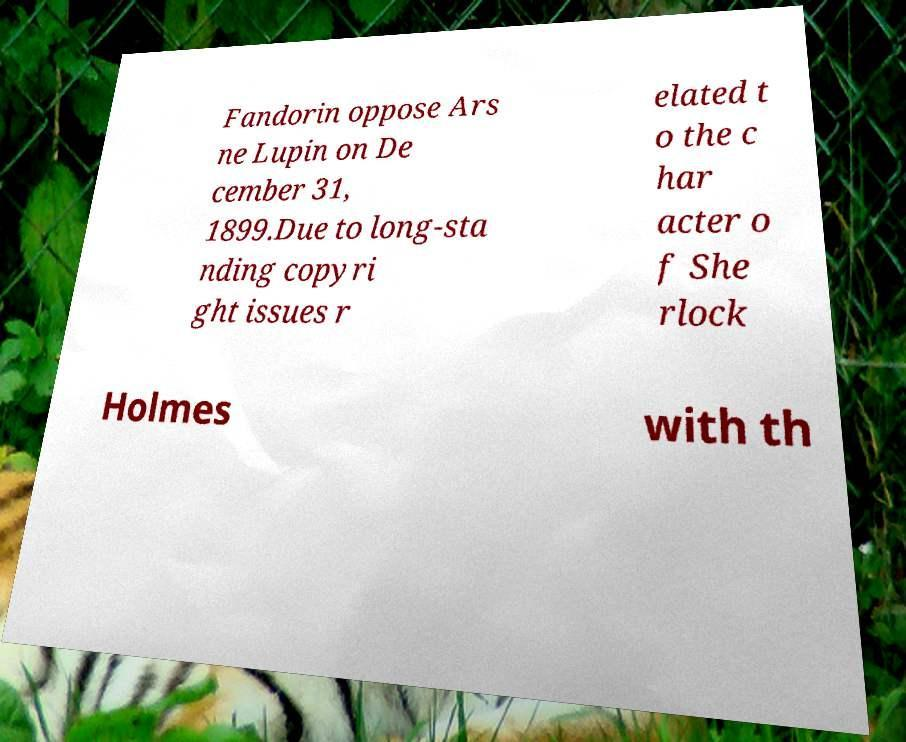Could you assist in decoding the text presented in this image and type it out clearly? Fandorin oppose Ars ne Lupin on De cember 31, 1899.Due to long-sta nding copyri ght issues r elated t o the c har acter o f She rlock Holmes with th 